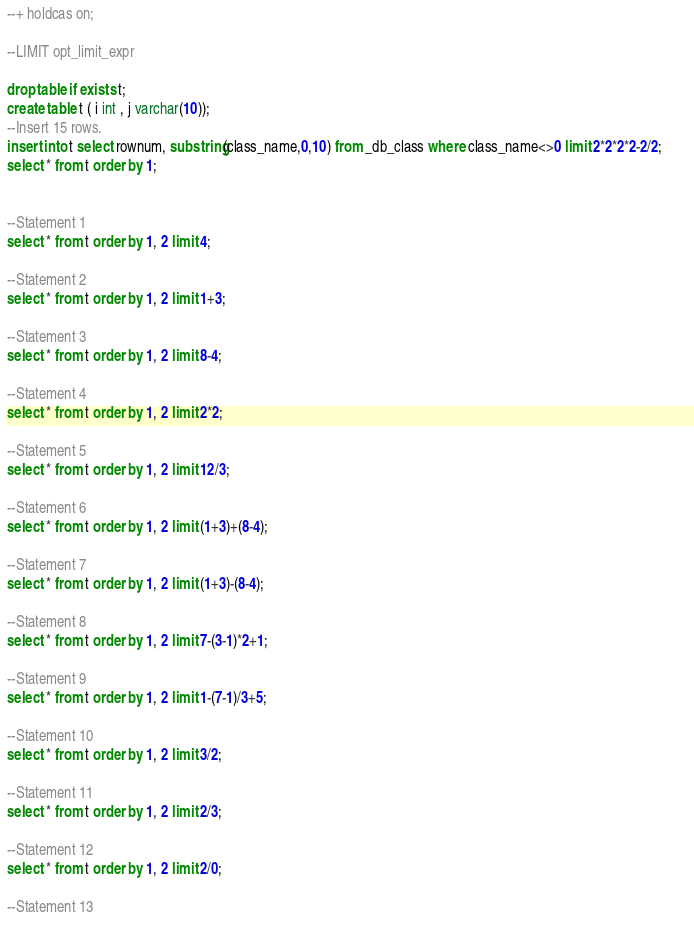Convert code to text. <code><loc_0><loc_0><loc_500><loc_500><_SQL_>--+ holdcas on;

--LIMIT opt_limit_expr 

drop table if exists t;
create table t ( i int , j varchar(10));
--Insert 15 rows. 
insert into t select rownum, substring(class_name,0,10) from _db_class where class_name<>0 limit 2*2*2*2-2/2;       
select * from t order by 1;


--Statement 1
select * from t order by 1, 2 limit 4;

--Statement 2
select * from t order by 1, 2 limit 1+3;

--Statement 3
select * from t order by 1, 2 limit 8-4;

--Statement 4
select * from t order by 1, 2 limit 2*2;

--Statement 5
select * from t order by 1, 2 limit 12/3;

--Statement 6
select * from t order by 1, 2 limit (1+3)+(8-4);

--Statement 7
select * from t order by 1, 2 limit (1+3)-(8-4);

--Statement 8
select * from t order by 1, 2 limit 7-(3-1)*2+1;

--Statement 9
select * from t order by 1, 2 limit 1-(7-1)/3+5;

--Statement 10
select * from t order by 1, 2 limit 3/2;

--Statement 11
select * from t order by 1, 2 limit 2/3;

--Statement 12
select * from t order by 1, 2 limit 2/0;

--Statement 13</code> 